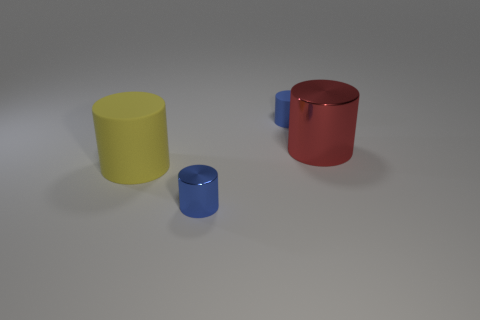How many large red cylinders are made of the same material as the yellow object?
Your answer should be very brief. 0. There is a tiny thing that is left of the tiny blue matte cylinder; how many blue metal objects are behind it?
Make the answer very short. 0. What number of red blocks are there?
Make the answer very short. 0. Is the material of the large red thing the same as the tiny cylinder that is behind the large yellow object?
Provide a short and direct response. No. There is a matte cylinder behind the yellow rubber object; is it the same color as the small metallic cylinder?
Give a very brief answer. Yes. The cylinder that is behind the yellow thing and left of the large metallic object is made of what material?
Provide a succinct answer. Rubber. How big is the yellow thing?
Make the answer very short. Large. Does the tiny metal cylinder have the same color as the metal thing that is on the right side of the tiny matte object?
Provide a succinct answer. No. How many other things are the same color as the tiny metal cylinder?
Provide a short and direct response. 1. Do the matte cylinder left of the blue matte object and the blue cylinder that is behind the large yellow thing have the same size?
Offer a terse response. No. 